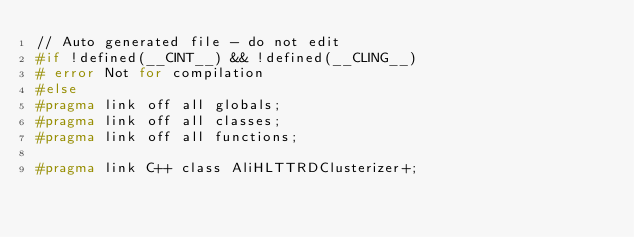<code> <loc_0><loc_0><loc_500><loc_500><_C_>// Auto generated file - do not edit
#if !defined(__CINT__) && !defined(__CLING__)
# error Not for compilation
#else 
#pragma link off all globals;
#pragma link off all classes;
#pragma link off all functions;

#pragma link C++ class AliHLTTRDClusterizer+;</code> 